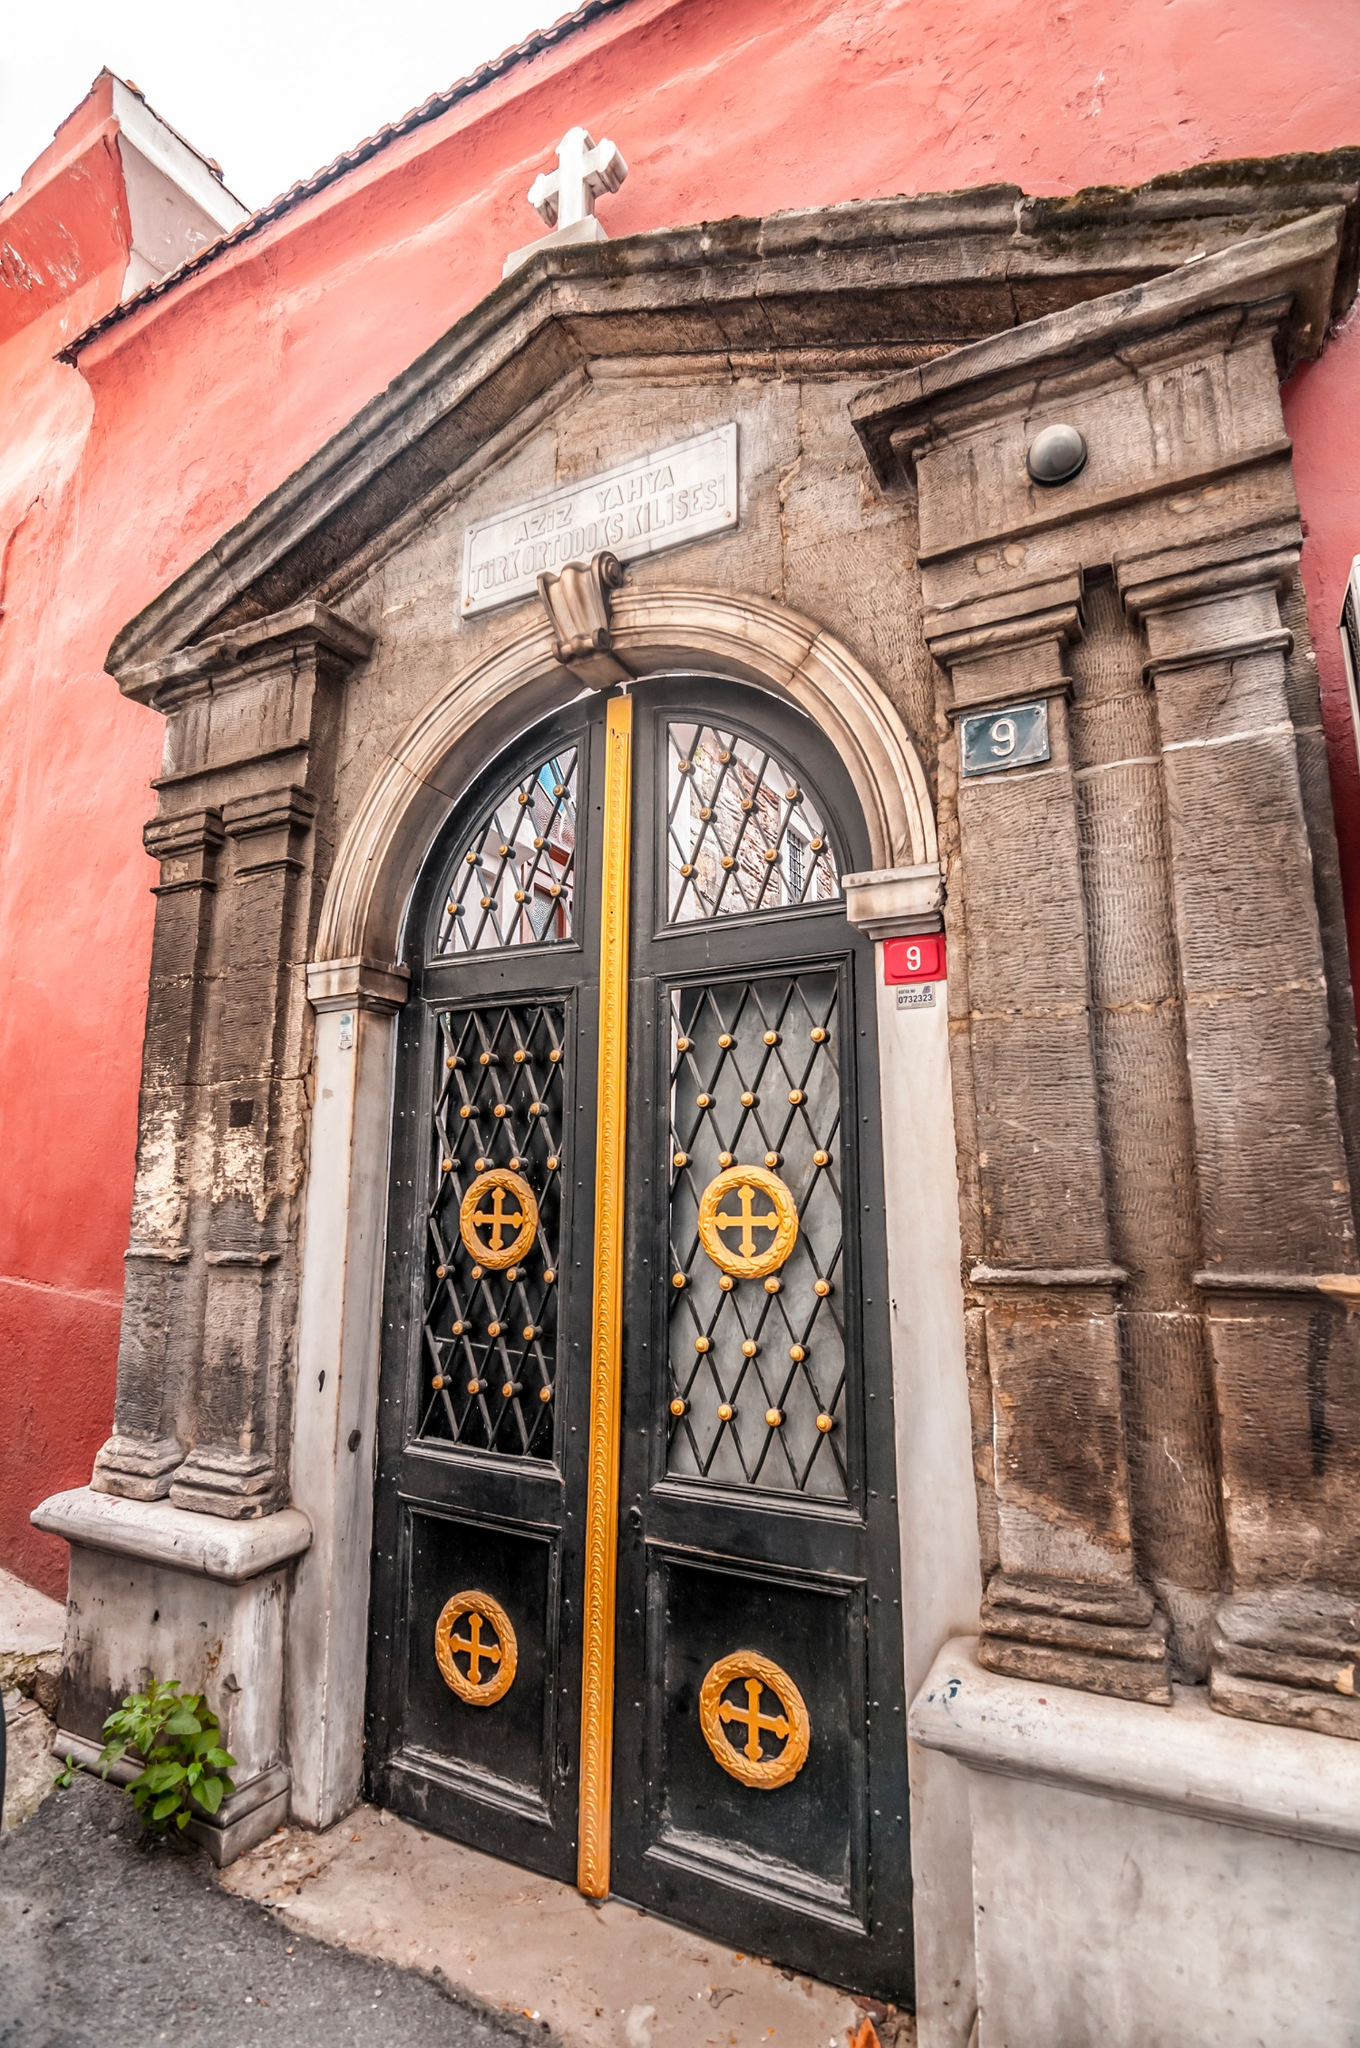Who might use this building, considering its design and features? This building is likely used by members of the Greek Orthodox community, as evidenced by the Greek inscription and religious symbols on the door. It appears to be a church or a chapel, serving as a place of worship, community gatherings, and possibly cultural events. The grandeur of the entrance indicates it might host significant religious ceremonies and be a central place for the local community to gather and practice their faith. 